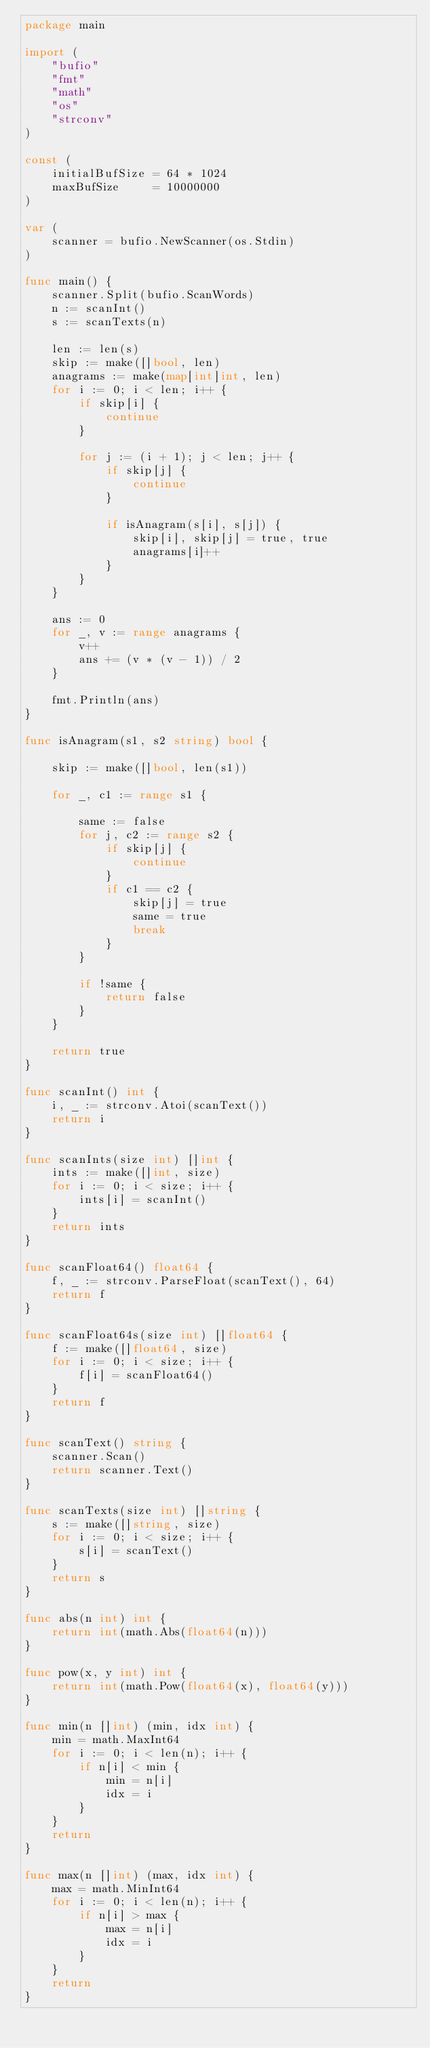<code> <loc_0><loc_0><loc_500><loc_500><_Go_>package main

import (
	"bufio"
	"fmt"
	"math"
	"os"
	"strconv"
)

const (
	initialBufSize = 64 * 1024
	maxBufSize     = 10000000
)

var (
	scanner = bufio.NewScanner(os.Stdin)
)

func main() {
	scanner.Split(bufio.ScanWords)
	n := scanInt()
	s := scanTexts(n)

	len := len(s)
	skip := make([]bool, len)
	anagrams := make(map[int]int, len)
	for i := 0; i < len; i++ {
		if skip[i] {
			continue
		}

		for j := (i + 1); j < len; j++ {
			if skip[j] {
				continue
			}

			if isAnagram(s[i], s[j]) {
				skip[i], skip[j] = true, true
				anagrams[i]++
			}
		}
	}

	ans := 0
	for _, v := range anagrams {
		v++
		ans += (v * (v - 1)) / 2
	}

	fmt.Println(ans)
}

func isAnagram(s1, s2 string) bool {

	skip := make([]bool, len(s1))

	for _, c1 := range s1 {

		same := false
		for j, c2 := range s2 {
			if skip[j] {
				continue
			}
			if c1 == c2 {
				skip[j] = true
				same = true
				break
			}
		}

		if !same {
			return false
		}
	}

	return true
}

func scanInt() int {
	i, _ := strconv.Atoi(scanText())
	return i
}

func scanInts(size int) []int {
	ints := make([]int, size)
	for i := 0; i < size; i++ {
		ints[i] = scanInt()
	}
	return ints
}

func scanFloat64() float64 {
	f, _ := strconv.ParseFloat(scanText(), 64)
	return f
}

func scanFloat64s(size int) []float64 {
	f := make([]float64, size)
	for i := 0; i < size; i++ {
		f[i] = scanFloat64()
	}
	return f
}

func scanText() string {
	scanner.Scan()
	return scanner.Text()
}

func scanTexts(size int) []string {
	s := make([]string, size)
	for i := 0; i < size; i++ {
		s[i] = scanText()
	}
	return s
}

func abs(n int) int {
	return int(math.Abs(float64(n)))
}

func pow(x, y int) int {
	return int(math.Pow(float64(x), float64(y)))
}

func min(n []int) (min, idx int) {
	min = math.MaxInt64
	for i := 0; i < len(n); i++ {
		if n[i] < min {
			min = n[i]
			idx = i
		}
	}
	return
}

func max(n []int) (max, idx int) {
	max = math.MinInt64
	for i := 0; i < len(n); i++ {
		if n[i] > max {
			max = n[i]
			idx = i
		}
	}
	return
}
</code> 